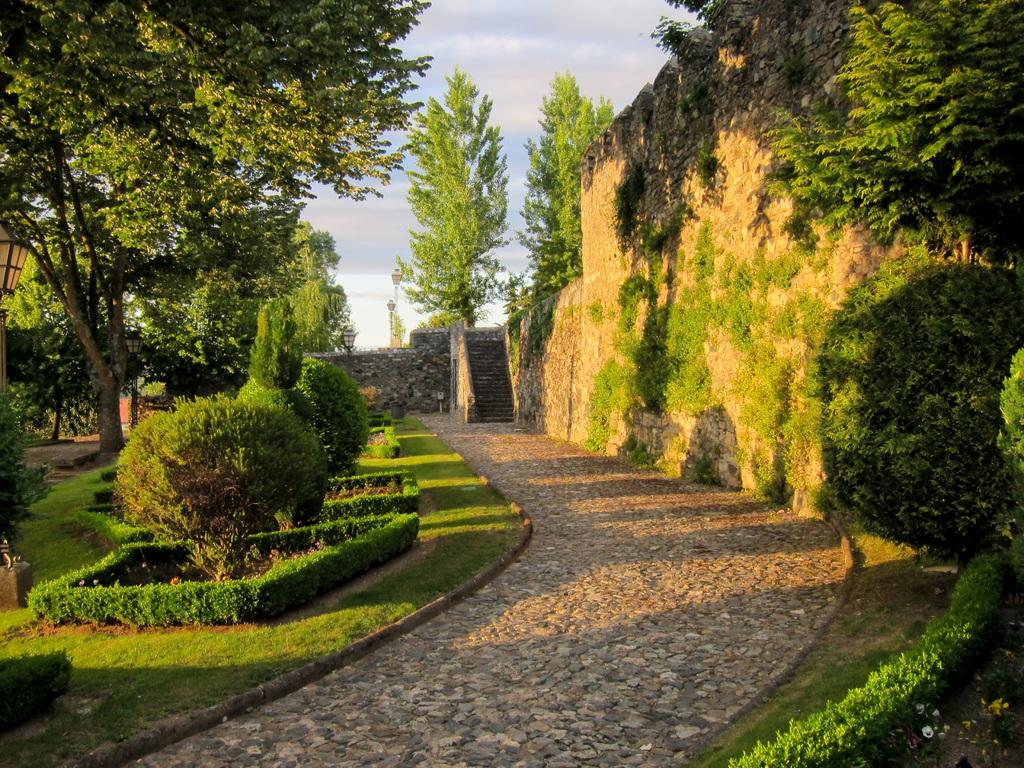What type of living organisms can be seen in the image? Plants and trees are visible in the image. What color are the plants and trees in the image? The plants and trees are green. What is visible in the background of the image? The sky is visible in the background of the image. What colors can be seen in the sky? The sky has white and blue colors. How many pigs are visible in the image? There are no pigs present in the image. What type of health advice can be seen on the trees in the image? There is no health advice visible on the trees in the image. 